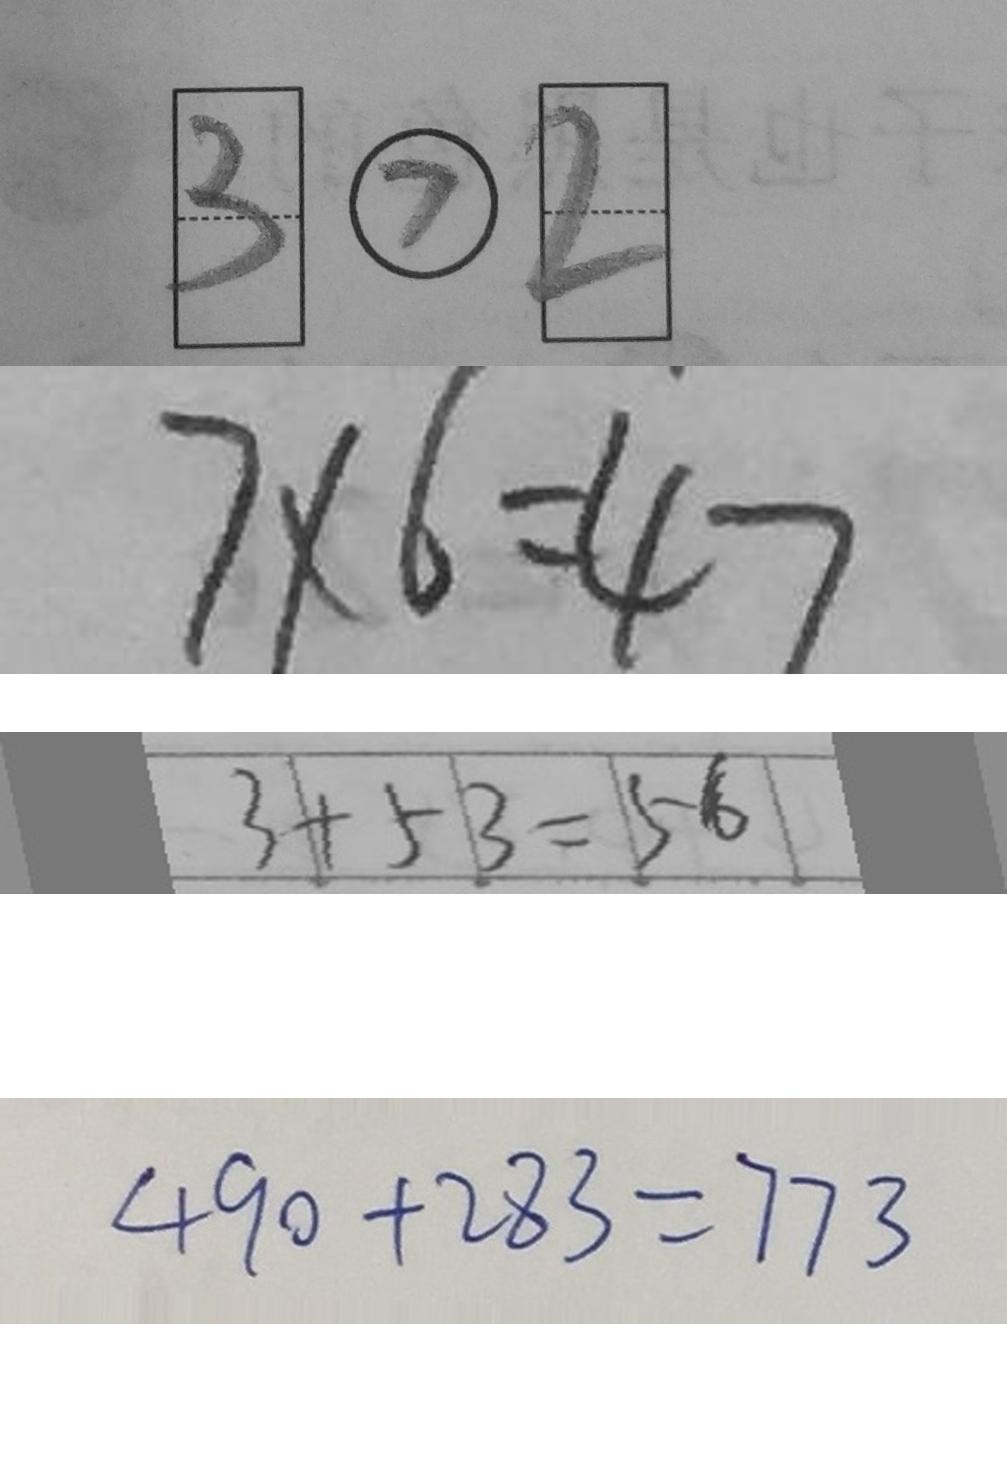Convert formula to latex. <formula><loc_0><loc_0><loc_500><loc_500>\boxed { 3 } \textcircled { > } \boxed { 2 } 
 7 \times 6 = 4 7 
 3 + 5 3 = 5 6 
 4 9 0 + 2 8 3 = 7 7 3</formula> 